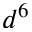Convert formula to latex. <formula><loc_0><loc_0><loc_500><loc_500>d ^ { 6 }</formula> 